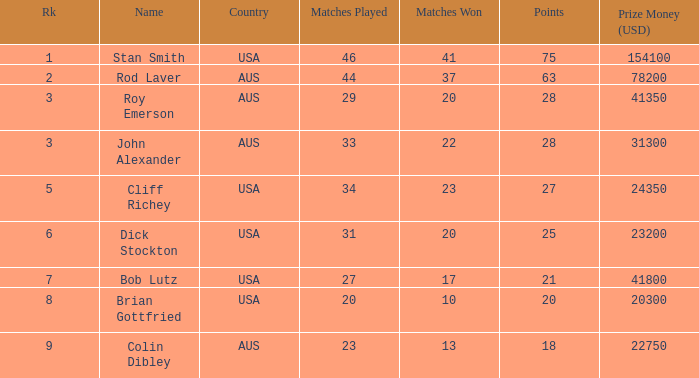What was the number of victories for the player who participated in 23 games? 13.0. 